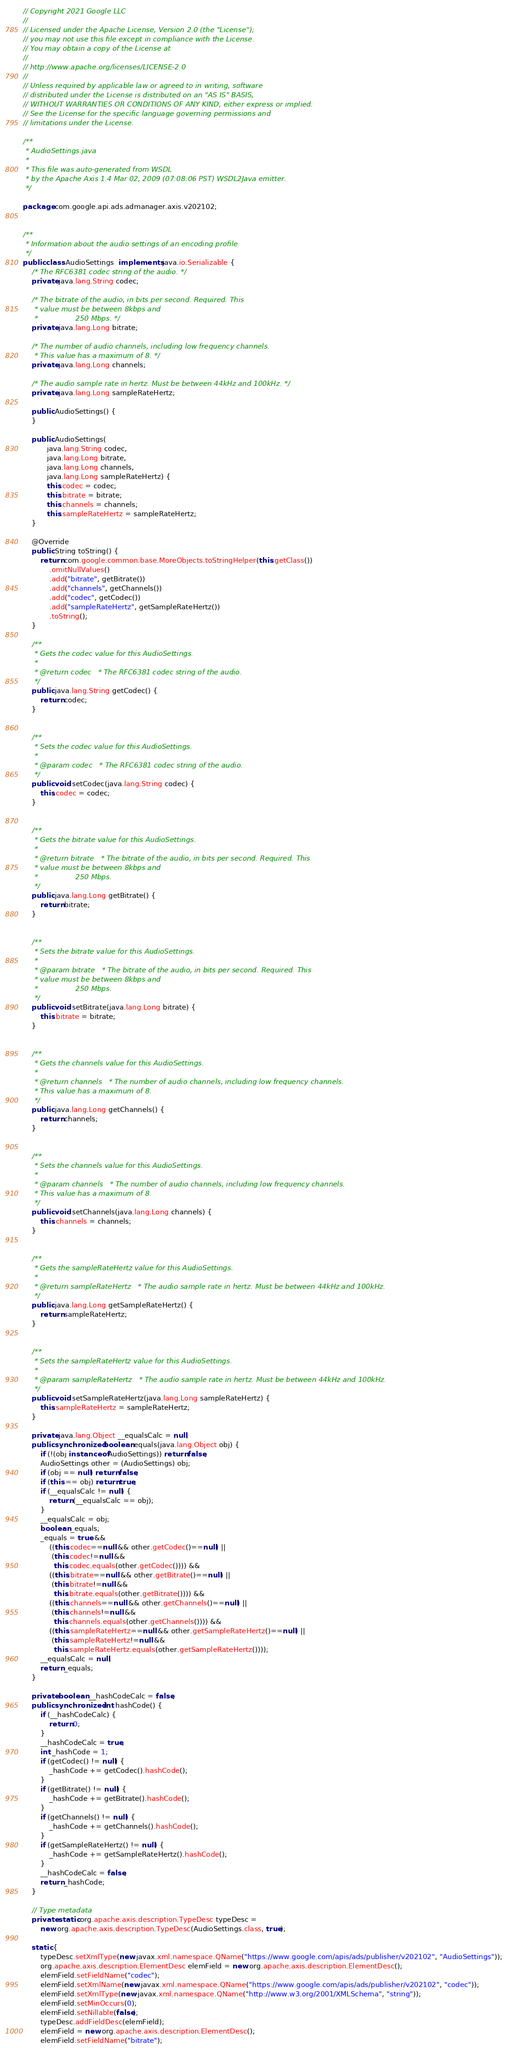Convert code to text. <code><loc_0><loc_0><loc_500><loc_500><_Java_>// Copyright 2021 Google LLC
//
// Licensed under the Apache License, Version 2.0 (the "License");
// you may not use this file except in compliance with the License.
// You may obtain a copy of the License at
//
// http://www.apache.org/licenses/LICENSE-2.0
//
// Unless required by applicable law or agreed to in writing, software
// distributed under the License is distributed on an "AS IS" BASIS,
// WITHOUT WARRANTIES OR CONDITIONS OF ANY KIND, either express or implied.
// See the License for the specific language governing permissions and
// limitations under the License.

/**
 * AudioSettings.java
 *
 * This file was auto-generated from WSDL
 * by the Apache Axis 1.4 Mar 02, 2009 (07:08:06 PST) WSDL2Java emitter.
 */

package com.google.api.ads.admanager.axis.v202102;


/**
 * Information about the audio settings of an encoding profile.
 */
public class AudioSettings  implements java.io.Serializable {
    /* The RFC6381 codec string of the audio. */
    private java.lang.String codec;

    /* The bitrate of the audio, in bits per second. Required. This
     * value must be between 8kbps and
     *                 250 Mbps. */
    private java.lang.Long bitrate;

    /* The number of audio channels, including low frequency channels.
     * This value has a maximum of 8. */
    private java.lang.Long channels;

    /* The audio sample rate in hertz. Must be between 44kHz and 100kHz. */
    private java.lang.Long sampleRateHertz;

    public AudioSettings() {
    }

    public AudioSettings(
           java.lang.String codec,
           java.lang.Long bitrate,
           java.lang.Long channels,
           java.lang.Long sampleRateHertz) {
           this.codec = codec;
           this.bitrate = bitrate;
           this.channels = channels;
           this.sampleRateHertz = sampleRateHertz;
    }

    @Override
    public String toString() {
        return com.google.common.base.MoreObjects.toStringHelper(this.getClass())
            .omitNullValues()
            .add("bitrate", getBitrate())
            .add("channels", getChannels())
            .add("codec", getCodec())
            .add("sampleRateHertz", getSampleRateHertz())
            .toString();
    }

    /**
     * Gets the codec value for this AudioSettings.
     * 
     * @return codec   * The RFC6381 codec string of the audio.
     */
    public java.lang.String getCodec() {
        return codec;
    }


    /**
     * Sets the codec value for this AudioSettings.
     * 
     * @param codec   * The RFC6381 codec string of the audio.
     */
    public void setCodec(java.lang.String codec) {
        this.codec = codec;
    }


    /**
     * Gets the bitrate value for this AudioSettings.
     * 
     * @return bitrate   * The bitrate of the audio, in bits per second. Required. This
     * value must be between 8kbps and
     *                 250 Mbps.
     */
    public java.lang.Long getBitrate() {
        return bitrate;
    }


    /**
     * Sets the bitrate value for this AudioSettings.
     * 
     * @param bitrate   * The bitrate of the audio, in bits per second. Required. This
     * value must be between 8kbps and
     *                 250 Mbps.
     */
    public void setBitrate(java.lang.Long bitrate) {
        this.bitrate = bitrate;
    }


    /**
     * Gets the channels value for this AudioSettings.
     * 
     * @return channels   * The number of audio channels, including low frequency channels.
     * This value has a maximum of 8.
     */
    public java.lang.Long getChannels() {
        return channels;
    }


    /**
     * Sets the channels value for this AudioSettings.
     * 
     * @param channels   * The number of audio channels, including low frequency channels.
     * This value has a maximum of 8.
     */
    public void setChannels(java.lang.Long channels) {
        this.channels = channels;
    }


    /**
     * Gets the sampleRateHertz value for this AudioSettings.
     * 
     * @return sampleRateHertz   * The audio sample rate in hertz. Must be between 44kHz and 100kHz.
     */
    public java.lang.Long getSampleRateHertz() {
        return sampleRateHertz;
    }


    /**
     * Sets the sampleRateHertz value for this AudioSettings.
     * 
     * @param sampleRateHertz   * The audio sample rate in hertz. Must be between 44kHz and 100kHz.
     */
    public void setSampleRateHertz(java.lang.Long sampleRateHertz) {
        this.sampleRateHertz = sampleRateHertz;
    }

    private java.lang.Object __equalsCalc = null;
    public synchronized boolean equals(java.lang.Object obj) {
        if (!(obj instanceof AudioSettings)) return false;
        AudioSettings other = (AudioSettings) obj;
        if (obj == null) return false;
        if (this == obj) return true;
        if (__equalsCalc != null) {
            return (__equalsCalc == obj);
        }
        __equalsCalc = obj;
        boolean _equals;
        _equals = true && 
            ((this.codec==null && other.getCodec()==null) || 
             (this.codec!=null &&
              this.codec.equals(other.getCodec()))) &&
            ((this.bitrate==null && other.getBitrate()==null) || 
             (this.bitrate!=null &&
              this.bitrate.equals(other.getBitrate()))) &&
            ((this.channels==null && other.getChannels()==null) || 
             (this.channels!=null &&
              this.channels.equals(other.getChannels()))) &&
            ((this.sampleRateHertz==null && other.getSampleRateHertz()==null) || 
             (this.sampleRateHertz!=null &&
              this.sampleRateHertz.equals(other.getSampleRateHertz())));
        __equalsCalc = null;
        return _equals;
    }

    private boolean __hashCodeCalc = false;
    public synchronized int hashCode() {
        if (__hashCodeCalc) {
            return 0;
        }
        __hashCodeCalc = true;
        int _hashCode = 1;
        if (getCodec() != null) {
            _hashCode += getCodec().hashCode();
        }
        if (getBitrate() != null) {
            _hashCode += getBitrate().hashCode();
        }
        if (getChannels() != null) {
            _hashCode += getChannels().hashCode();
        }
        if (getSampleRateHertz() != null) {
            _hashCode += getSampleRateHertz().hashCode();
        }
        __hashCodeCalc = false;
        return _hashCode;
    }

    // Type metadata
    private static org.apache.axis.description.TypeDesc typeDesc =
        new org.apache.axis.description.TypeDesc(AudioSettings.class, true);

    static {
        typeDesc.setXmlType(new javax.xml.namespace.QName("https://www.google.com/apis/ads/publisher/v202102", "AudioSettings"));
        org.apache.axis.description.ElementDesc elemField = new org.apache.axis.description.ElementDesc();
        elemField.setFieldName("codec");
        elemField.setXmlName(new javax.xml.namespace.QName("https://www.google.com/apis/ads/publisher/v202102", "codec"));
        elemField.setXmlType(new javax.xml.namespace.QName("http://www.w3.org/2001/XMLSchema", "string"));
        elemField.setMinOccurs(0);
        elemField.setNillable(false);
        typeDesc.addFieldDesc(elemField);
        elemField = new org.apache.axis.description.ElementDesc();
        elemField.setFieldName("bitrate");</code> 